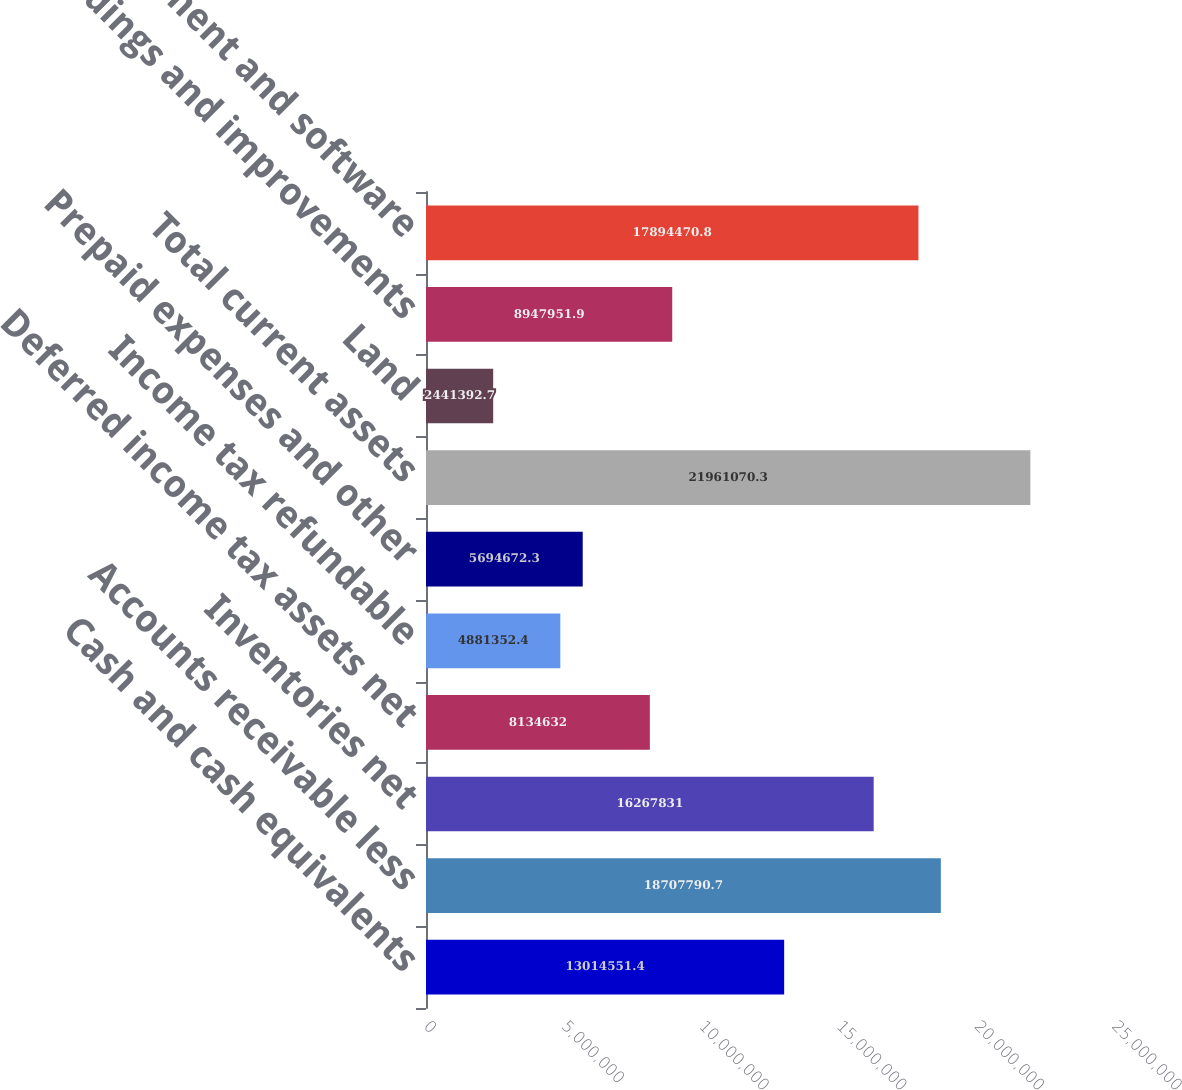Convert chart. <chart><loc_0><loc_0><loc_500><loc_500><bar_chart><fcel>Cash and cash equivalents<fcel>Accounts receivable less<fcel>Inventories net<fcel>Deferred income tax assets net<fcel>Income tax refundable<fcel>Prepaid expenses and other<fcel>Total current assets<fcel>Land<fcel>Buildings and improvements<fcel>Equipment and software<nl><fcel>1.30146e+07<fcel>1.87078e+07<fcel>1.62678e+07<fcel>8.13463e+06<fcel>4.88135e+06<fcel>5.69467e+06<fcel>2.19611e+07<fcel>2.44139e+06<fcel>8.94795e+06<fcel>1.78945e+07<nl></chart> 